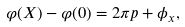Convert formula to latex. <formula><loc_0><loc_0><loc_500><loc_500>\varphi ( X ) - \varphi ( 0 ) = 2 \pi p + \phi _ { x } ,</formula> 